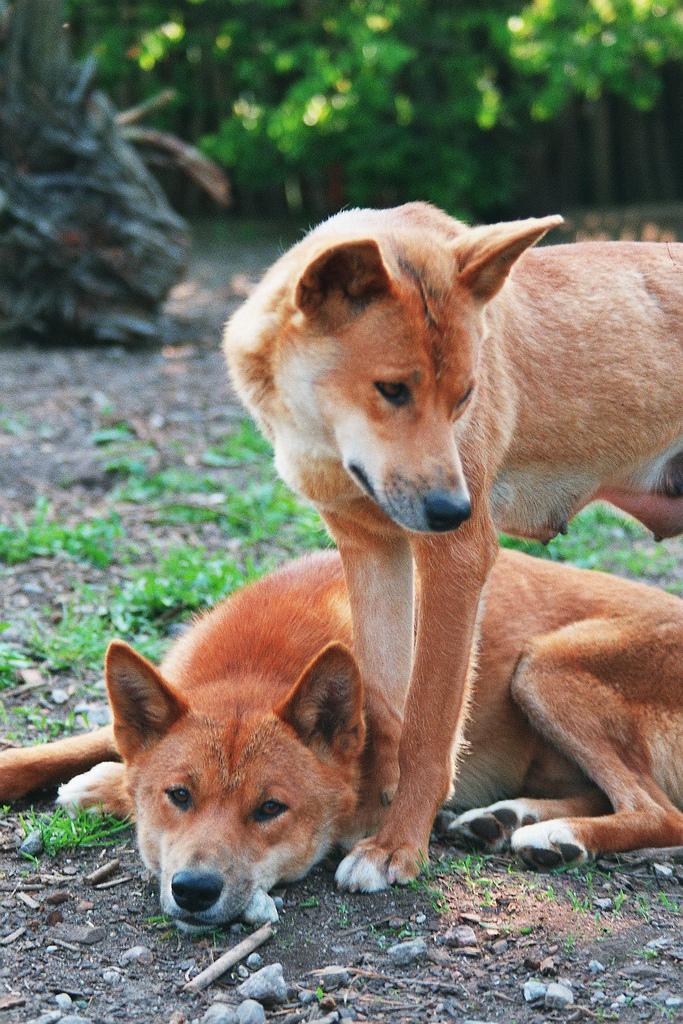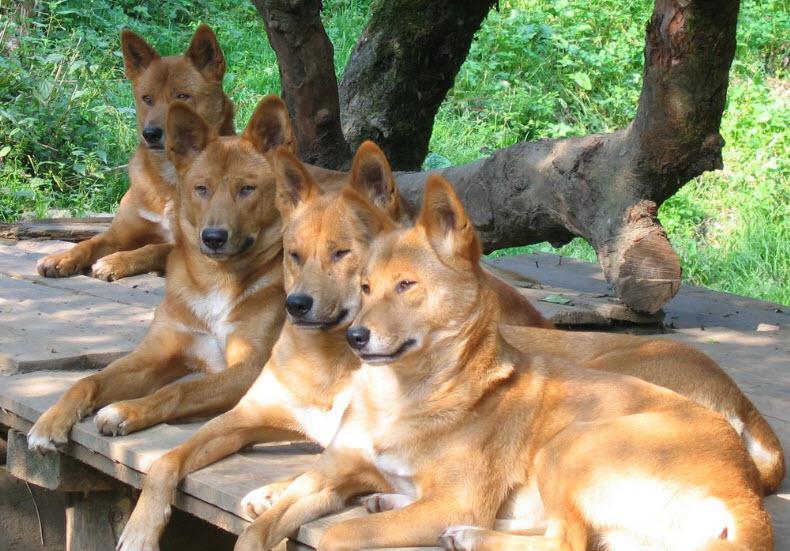The first image is the image on the left, the second image is the image on the right. Given the left and right images, does the statement "dogs facing the camera straight on" hold true? Answer yes or no. No. The first image is the image on the left, the second image is the image on the right. Assess this claim about the two images: "There are multiple canine laying down with there feet in front of them.". Correct or not? Answer yes or no. Yes. 